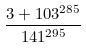Convert formula to latex. <formula><loc_0><loc_0><loc_500><loc_500>\frac { 3 + 1 0 3 ^ { 2 8 5 } } { 1 4 1 ^ { 2 9 5 } }</formula> 